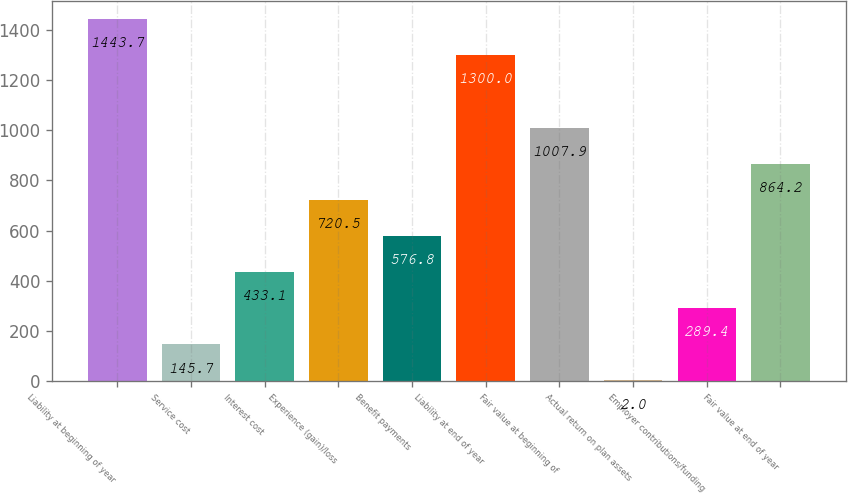Convert chart. <chart><loc_0><loc_0><loc_500><loc_500><bar_chart><fcel>Liability at beginning of year<fcel>Service cost<fcel>Interest cost<fcel>Experience (gain)/loss<fcel>Benefit payments<fcel>Liability at end of year<fcel>Fair value at beginning of<fcel>Actual return on plan assets<fcel>Employer contributions/funding<fcel>Fair value at end of year<nl><fcel>1443.7<fcel>145.7<fcel>433.1<fcel>720.5<fcel>576.8<fcel>1300<fcel>1007.9<fcel>2<fcel>289.4<fcel>864.2<nl></chart> 